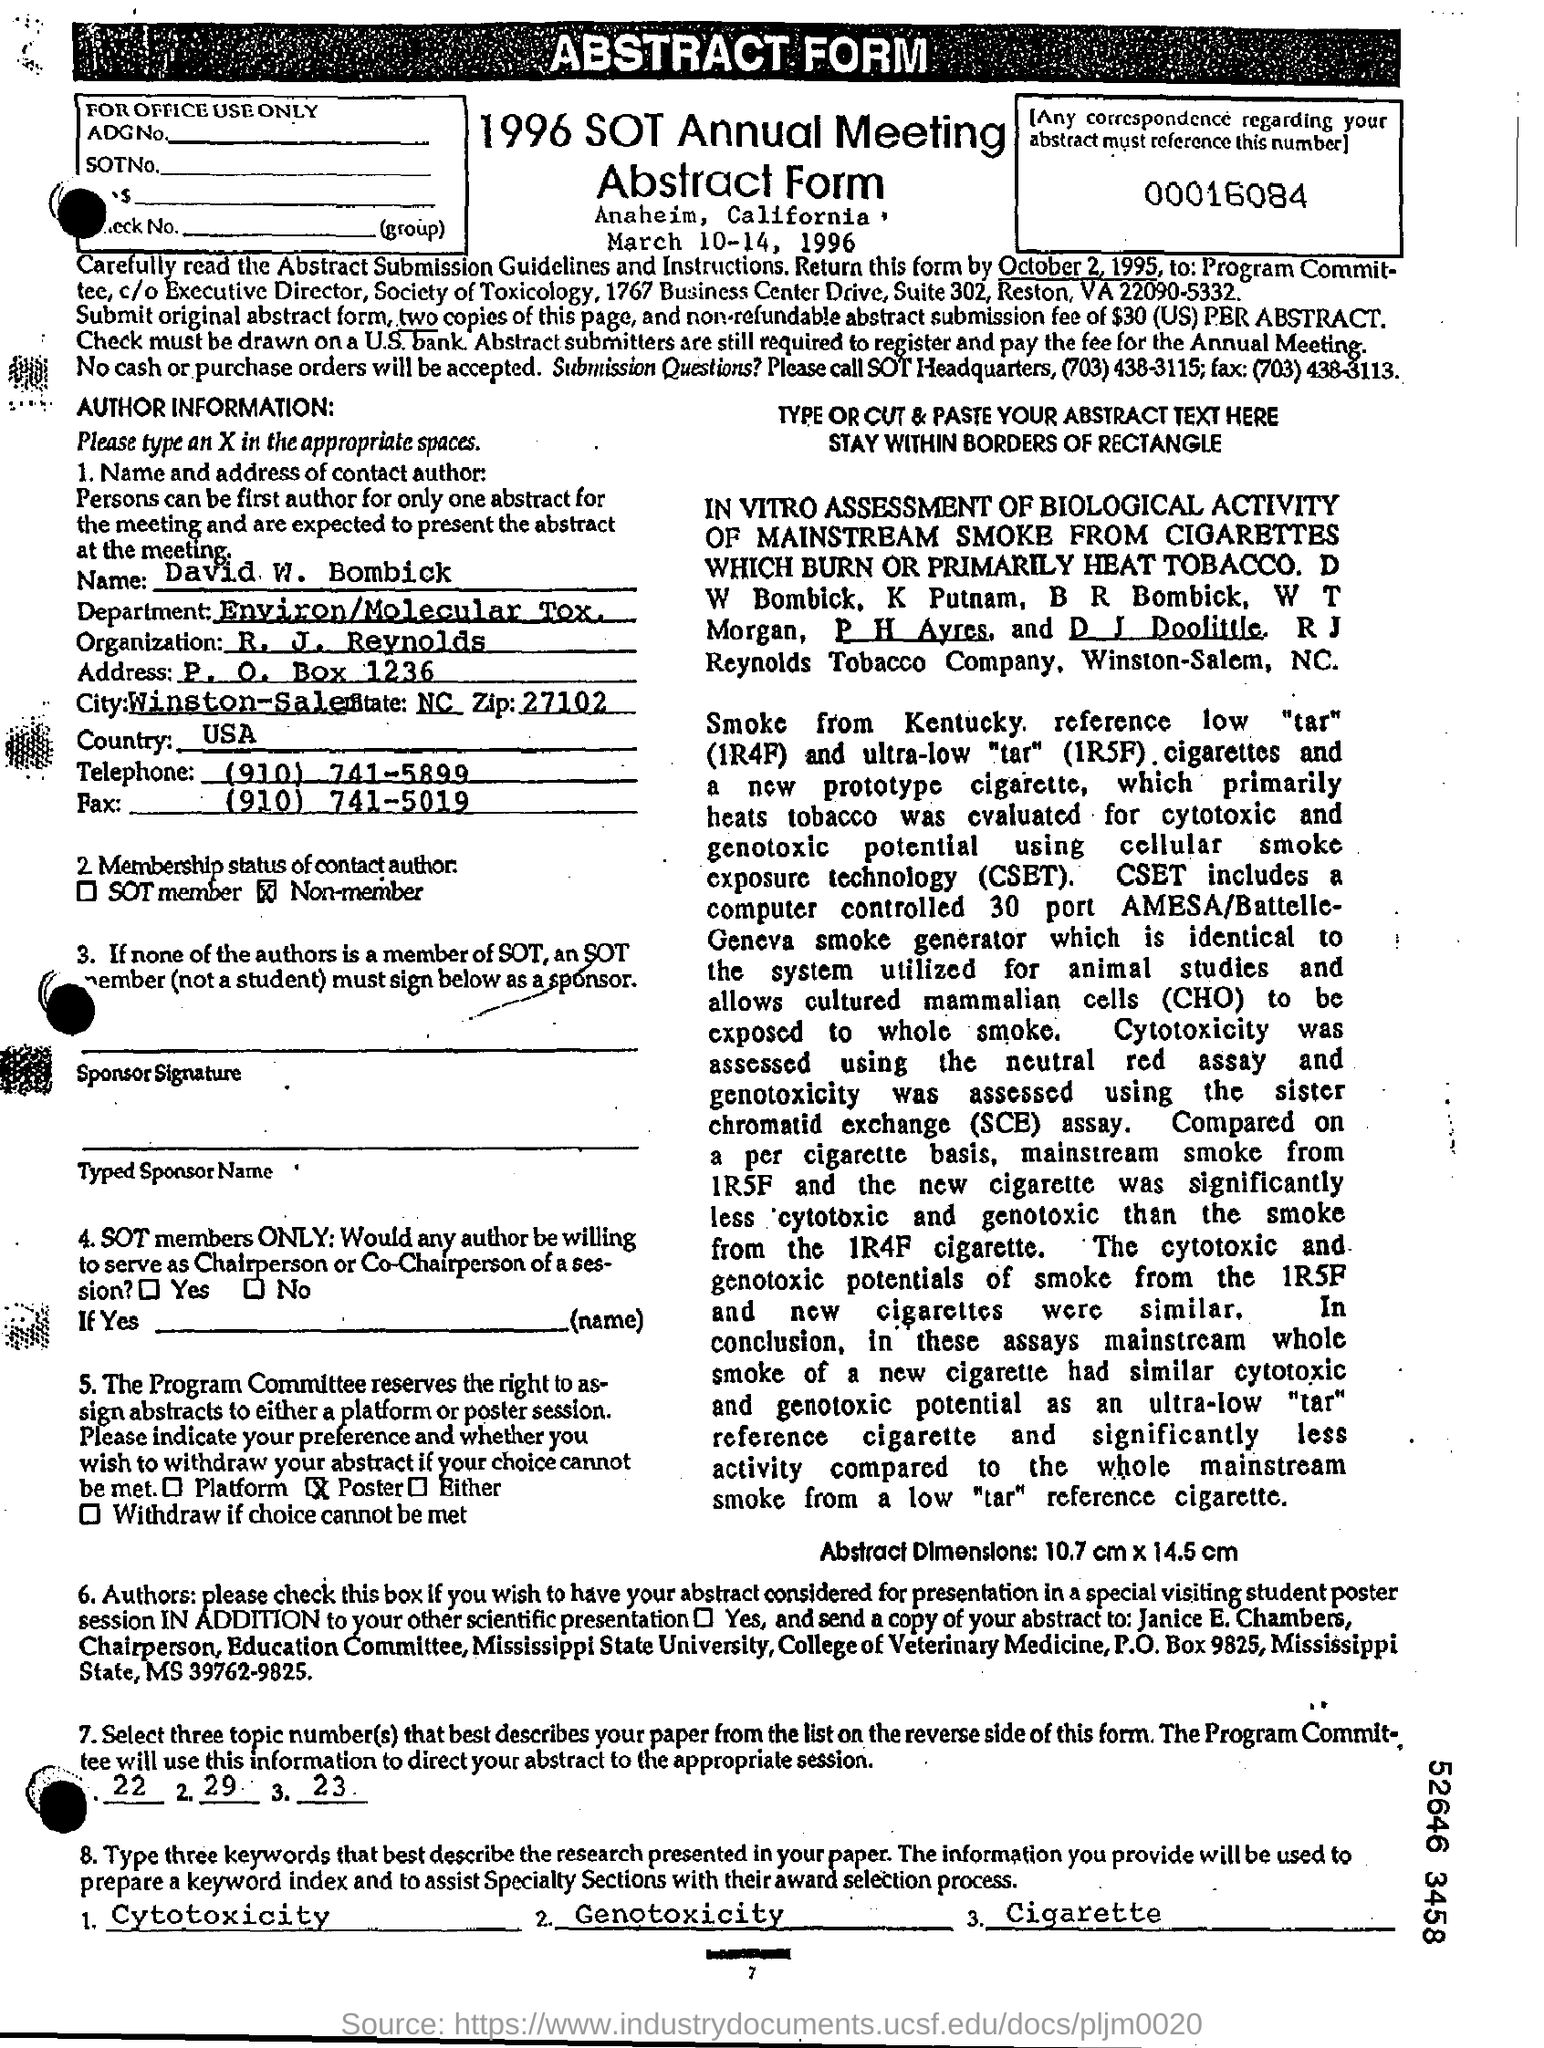What is written in the top of the document ?
Offer a terse response. Abstract form. What is written in the Organization Field ?
Offer a terse response. R. J. Reynolds. What is the Author Name ?
Keep it short and to the point. David w. bombick. What is the Fax Number ?
Ensure brevity in your answer.  (910) 741-5019. What is mentioned in the Department Field ?
Your response must be concise. Environ/Molecular tox. What is the Telephone Number ?
Ensure brevity in your answer.  (910) 741-5899. 